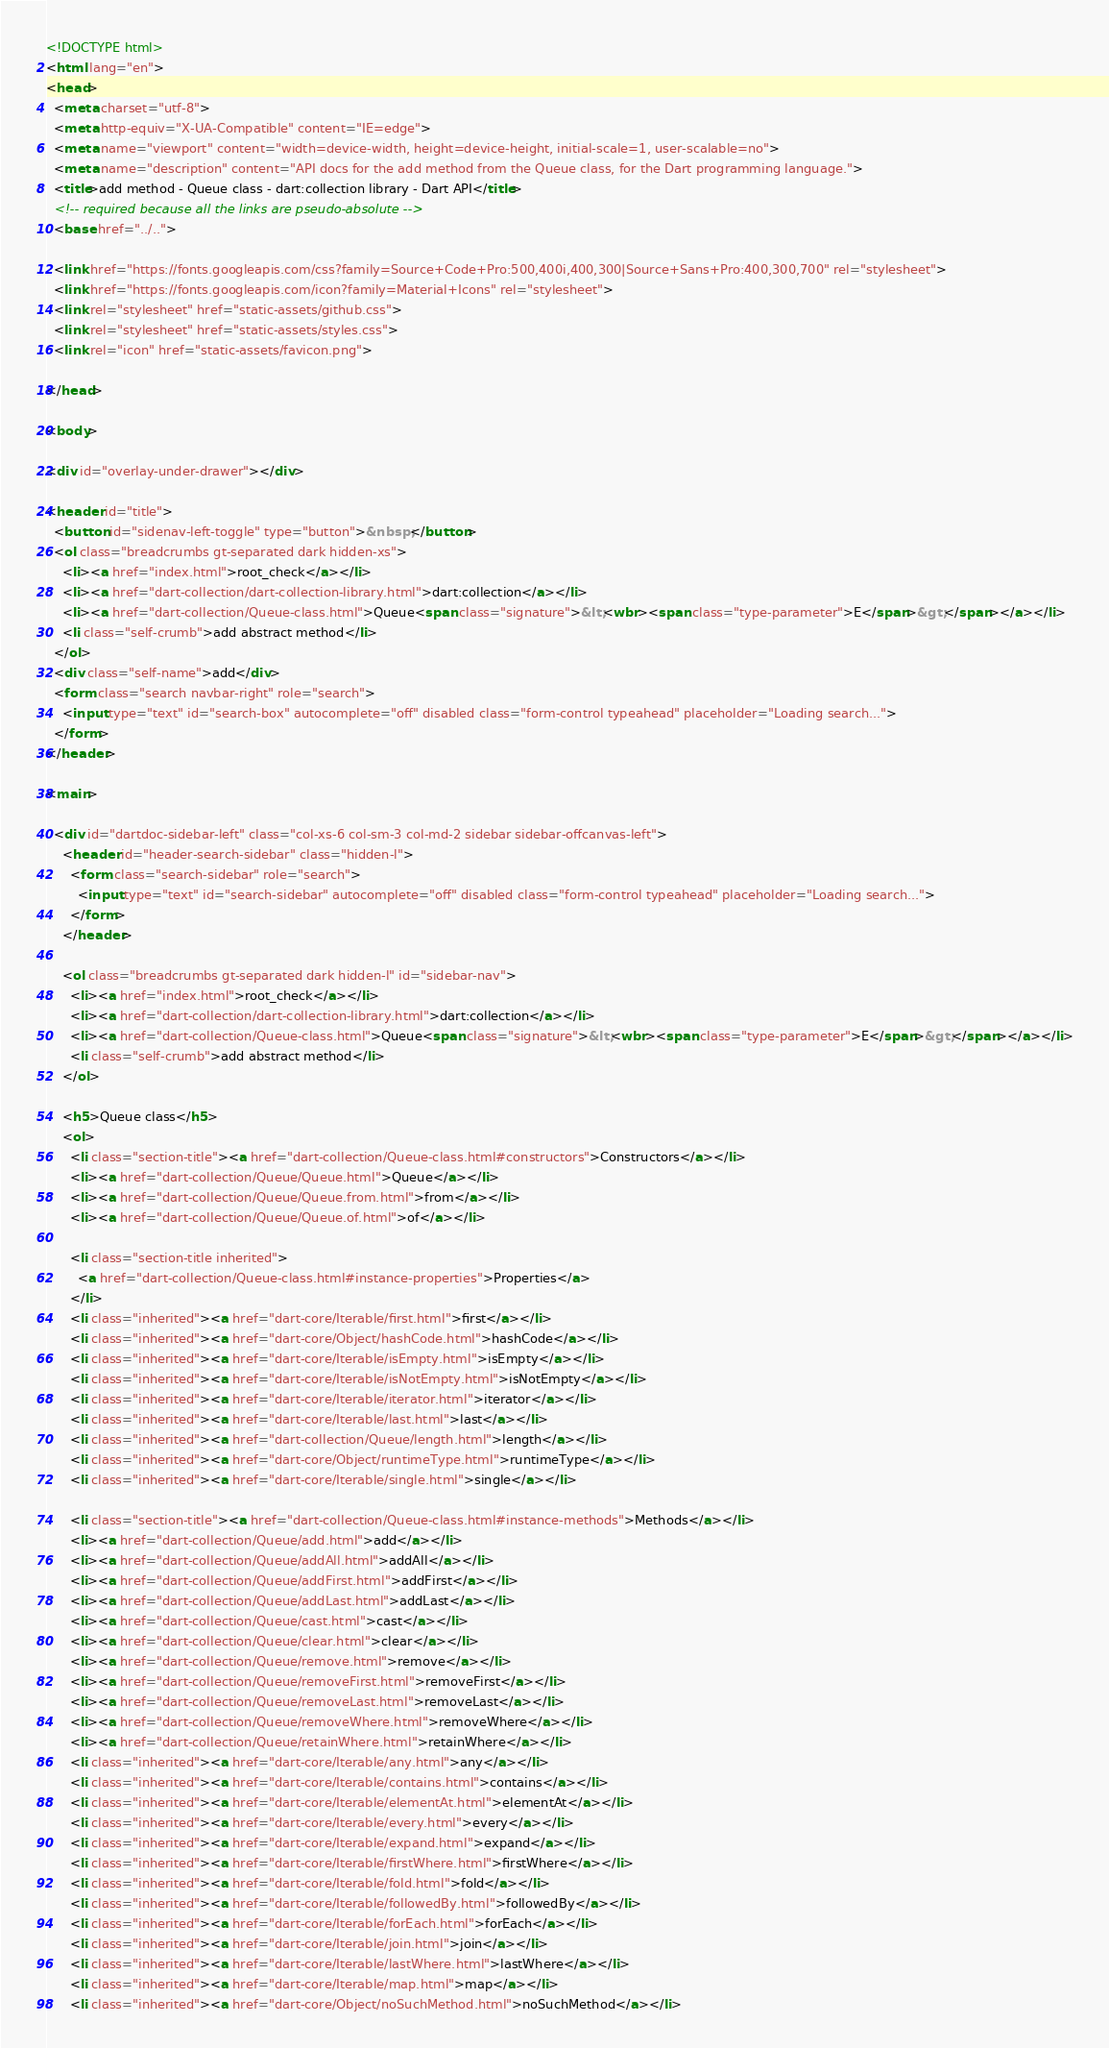<code> <loc_0><loc_0><loc_500><loc_500><_HTML_><!DOCTYPE html>
<html lang="en">
<head>
  <meta charset="utf-8">
  <meta http-equiv="X-UA-Compatible" content="IE=edge">
  <meta name="viewport" content="width=device-width, height=device-height, initial-scale=1, user-scalable=no">
  <meta name="description" content="API docs for the add method from the Queue class, for the Dart programming language.">
  <title>add method - Queue class - dart:collection library - Dart API</title>
  <!-- required because all the links are pseudo-absolute -->
  <base href="../..">

  <link href="https://fonts.googleapis.com/css?family=Source+Code+Pro:500,400i,400,300|Source+Sans+Pro:400,300,700" rel="stylesheet">
  <link href="https://fonts.googleapis.com/icon?family=Material+Icons" rel="stylesheet">
  <link rel="stylesheet" href="static-assets/github.css">
  <link rel="stylesheet" href="static-assets/styles.css">
  <link rel="icon" href="static-assets/favicon.png">
  
</head>

<body>

<div id="overlay-under-drawer"></div>

<header id="title">
  <button id="sidenav-left-toggle" type="button">&nbsp;</button>
  <ol class="breadcrumbs gt-separated dark hidden-xs">
    <li><a href="index.html">root_check</a></li>
    <li><a href="dart-collection/dart-collection-library.html">dart:collection</a></li>
    <li><a href="dart-collection/Queue-class.html">Queue<span class="signature">&lt;<wbr><span class="type-parameter">E</span>&gt;</span></a></li>
    <li class="self-crumb">add abstract method</li>
  </ol>
  <div class="self-name">add</div>
  <form class="search navbar-right" role="search">
    <input type="text" id="search-box" autocomplete="off" disabled class="form-control typeahead" placeholder="Loading search...">
  </form>
</header>

<main>

  <div id="dartdoc-sidebar-left" class="col-xs-6 col-sm-3 col-md-2 sidebar sidebar-offcanvas-left">
    <header id="header-search-sidebar" class="hidden-l">
      <form class="search-sidebar" role="search">
        <input type="text" id="search-sidebar" autocomplete="off" disabled class="form-control typeahead" placeholder="Loading search...">
      </form>
    </header>
    
    <ol class="breadcrumbs gt-separated dark hidden-l" id="sidebar-nav">
      <li><a href="index.html">root_check</a></li>
      <li><a href="dart-collection/dart-collection-library.html">dart:collection</a></li>
      <li><a href="dart-collection/Queue-class.html">Queue<span class="signature">&lt;<wbr><span class="type-parameter">E</span>&gt;</span></a></li>
      <li class="self-crumb">add abstract method</li>
    </ol>
    
    <h5>Queue class</h5>
    <ol>
      <li class="section-title"><a href="dart-collection/Queue-class.html#constructors">Constructors</a></li>
      <li><a href="dart-collection/Queue/Queue.html">Queue</a></li>
      <li><a href="dart-collection/Queue/Queue.from.html">from</a></li>
      <li><a href="dart-collection/Queue/Queue.of.html">of</a></li>
    
      <li class="section-title inherited">
        <a href="dart-collection/Queue-class.html#instance-properties">Properties</a>
      </li>
      <li class="inherited"><a href="dart-core/Iterable/first.html">first</a></li>
      <li class="inherited"><a href="dart-core/Object/hashCode.html">hashCode</a></li>
      <li class="inherited"><a href="dart-core/Iterable/isEmpty.html">isEmpty</a></li>
      <li class="inherited"><a href="dart-core/Iterable/isNotEmpty.html">isNotEmpty</a></li>
      <li class="inherited"><a href="dart-core/Iterable/iterator.html">iterator</a></li>
      <li class="inherited"><a href="dart-core/Iterable/last.html">last</a></li>
      <li class="inherited"><a href="dart-collection/Queue/length.html">length</a></li>
      <li class="inherited"><a href="dart-core/Object/runtimeType.html">runtimeType</a></li>
      <li class="inherited"><a href="dart-core/Iterable/single.html">single</a></li>
    
      <li class="section-title"><a href="dart-collection/Queue-class.html#instance-methods">Methods</a></li>
      <li><a href="dart-collection/Queue/add.html">add</a></li>
      <li><a href="dart-collection/Queue/addAll.html">addAll</a></li>
      <li><a href="dart-collection/Queue/addFirst.html">addFirst</a></li>
      <li><a href="dart-collection/Queue/addLast.html">addLast</a></li>
      <li><a href="dart-collection/Queue/cast.html">cast</a></li>
      <li><a href="dart-collection/Queue/clear.html">clear</a></li>
      <li><a href="dart-collection/Queue/remove.html">remove</a></li>
      <li><a href="dart-collection/Queue/removeFirst.html">removeFirst</a></li>
      <li><a href="dart-collection/Queue/removeLast.html">removeLast</a></li>
      <li><a href="dart-collection/Queue/removeWhere.html">removeWhere</a></li>
      <li><a href="dart-collection/Queue/retainWhere.html">retainWhere</a></li>
      <li class="inherited"><a href="dart-core/Iterable/any.html">any</a></li>
      <li class="inherited"><a href="dart-core/Iterable/contains.html">contains</a></li>
      <li class="inherited"><a href="dart-core/Iterable/elementAt.html">elementAt</a></li>
      <li class="inherited"><a href="dart-core/Iterable/every.html">every</a></li>
      <li class="inherited"><a href="dart-core/Iterable/expand.html">expand</a></li>
      <li class="inherited"><a href="dart-core/Iterable/firstWhere.html">firstWhere</a></li>
      <li class="inherited"><a href="dart-core/Iterable/fold.html">fold</a></li>
      <li class="inherited"><a href="dart-core/Iterable/followedBy.html">followedBy</a></li>
      <li class="inherited"><a href="dart-core/Iterable/forEach.html">forEach</a></li>
      <li class="inherited"><a href="dart-core/Iterable/join.html">join</a></li>
      <li class="inherited"><a href="dart-core/Iterable/lastWhere.html">lastWhere</a></li>
      <li class="inherited"><a href="dart-core/Iterable/map.html">map</a></li>
      <li class="inherited"><a href="dart-core/Object/noSuchMethod.html">noSuchMethod</a></li></code> 